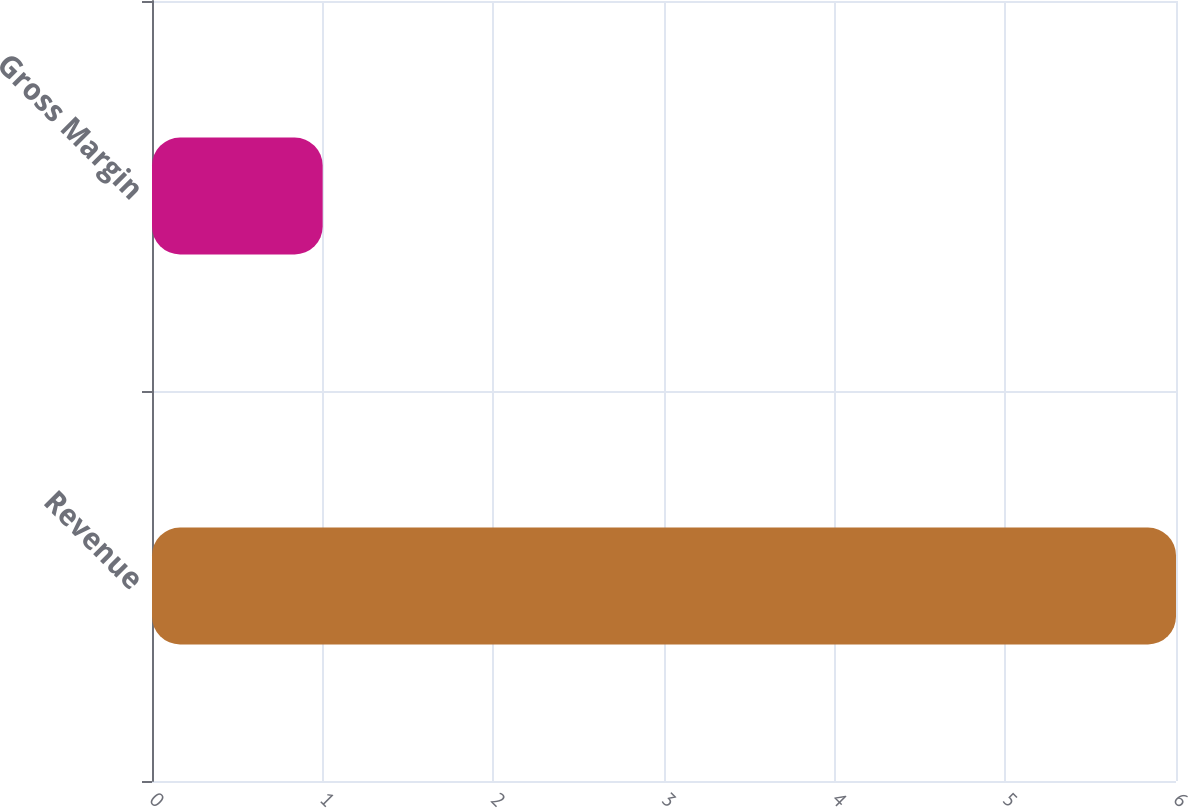<chart> <loc_0><loc_0><loc_500><loc_500><bar_chart><fcel>Revenue<fcel>Gross Margin<nl><fcel>6<fcel>1<nl></chart> 